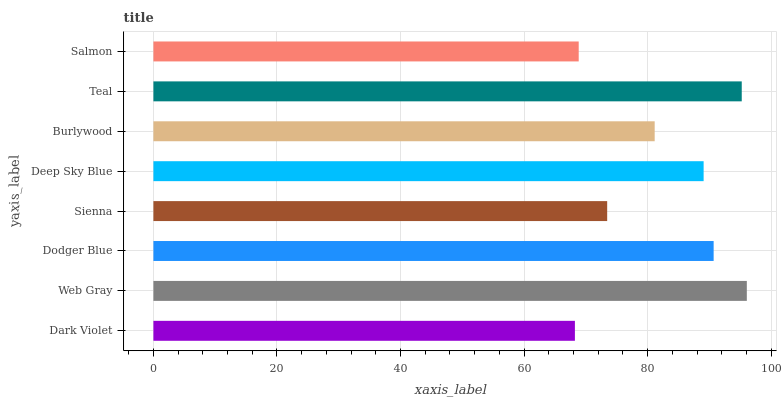Is Dark Violet the minimum?
Answer yes or no. Yes. Is Web Gray the maximum?
Answer yes or no. Yes. Is Dodger Blue the minimum?
Answer yes or no. No. Is Dodger Blue the maximum?
Answer yes or no. No. Is Web Gray greater than Dodger Blue?
Answer yes or no. Yes. Is Dodger Blue less than Web Gray?
Answer yes or no. Yes. Is Dodger Blue greater than Web Gray?
Answer yes or no. No. Is Web Gray less than Dodger Blue?
Answer yes or no. No. Is Deep Sky Blue the high median?
Answer yes or no. Yes. Is Burlywood the low median?
Answer yes or no. Yes. Is Web Gray the high median?
Answer yes or no. No. Is Dodger Blue the low median?
Answer yes or no. No. 